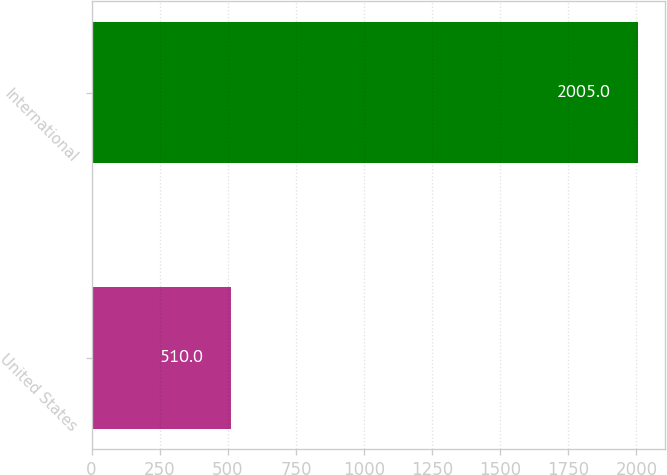Convert chart to OTSL. <chart><loc_0><loc_0><loc_500><loc_500><bar_chart><fcel>United States<fcel>International<nl><fcel>510<fcel>2005<nl></chart> 